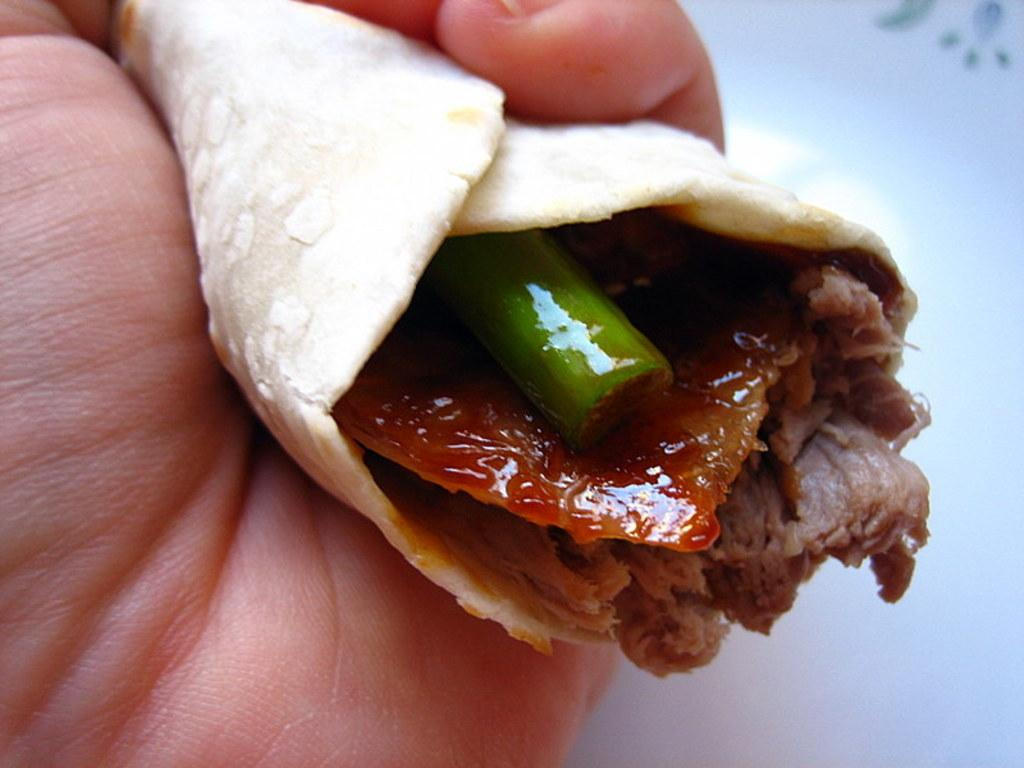What can be seen in the image? There is a hand in the image. What is the hand doing in the image? The hand is holding some food. What type of note is being played by the hand in the image? There is no musical instrument or note being played in the image; it only shows a hand holding food. 